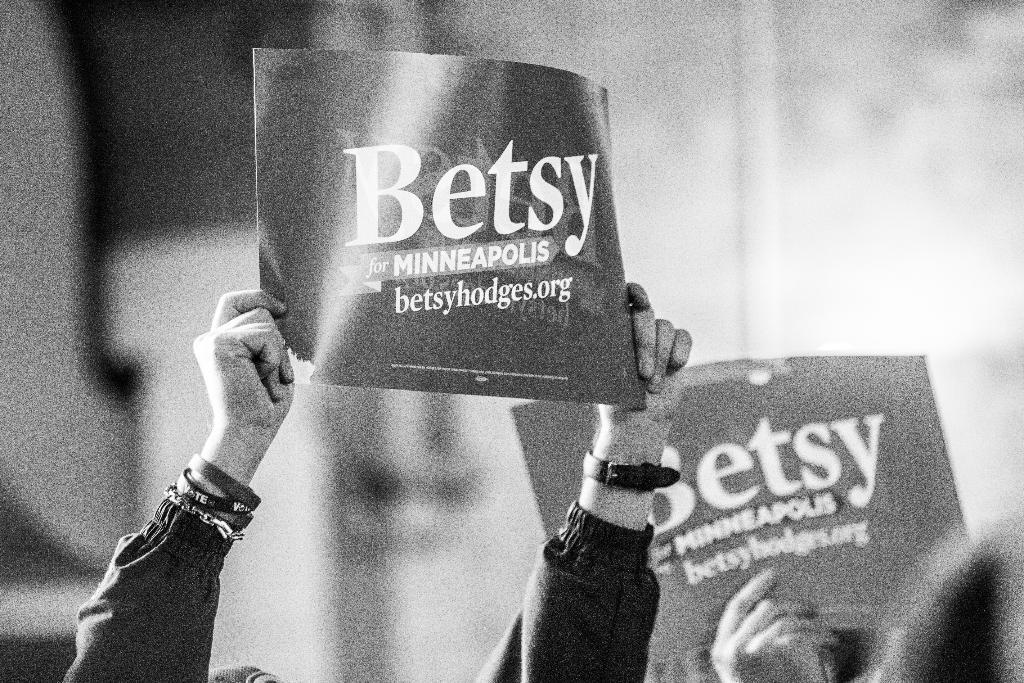What type of objects are the humans holding in the image? The humans are holding placards in the image. What can be found on the placards? The placards have text on them. What is visible in the background of the image? There is a wall in the background of the image. Can you see any cannons or toothbrushes in the image? No, there are no cannons or toothbrushes present in the image. Are there any fairies visible in the image? No, there are no fairies visible in the image. 